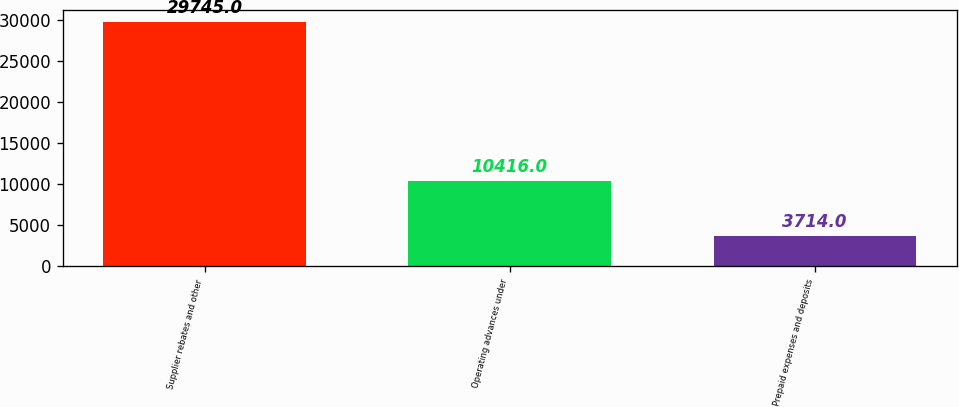Convert chart. <chart><loc_0><loc_0><loc_500><loc_500><bar_chart><fcel>Supplier rebates and other<fcel>Operating advances under<fcel>Prepaid expenses and deposits<nl><fcel>29745<fcel>10416<fcel>3714<nl></chart> 